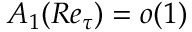<formula> <loc_0><loc_0><loc_500><loc_500>A _ { 1 } ( R e _ { \tau } ) = o ( 1 )</formula> 